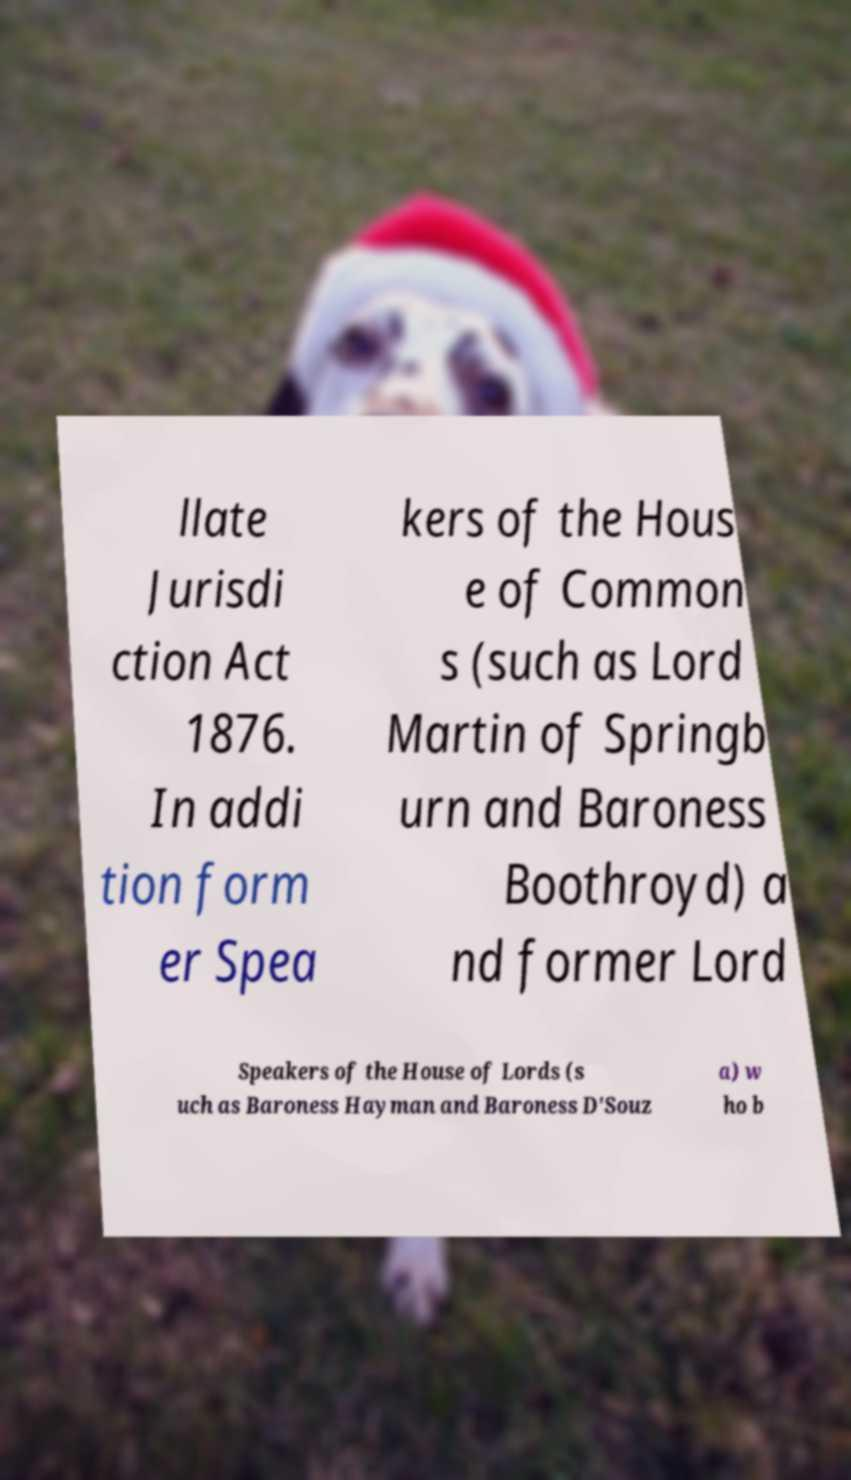Please read and relay the text visible in this image. What does it say? llate Jurisdi ction Act 1876. In addi tion form er Spea kers of the Hous e of Common s (such as Lord Martin of Springb urn and Baroness Boothroyd) a nd former Lord Speakers of the House of Lords (s uch as Baroness Hayman and Baroness D'Souz a) w ho b 